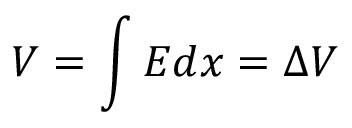<formula> <loc_0><loc_0><loc_500><loc_500>V = \int E d x = \Delta V</formula> 